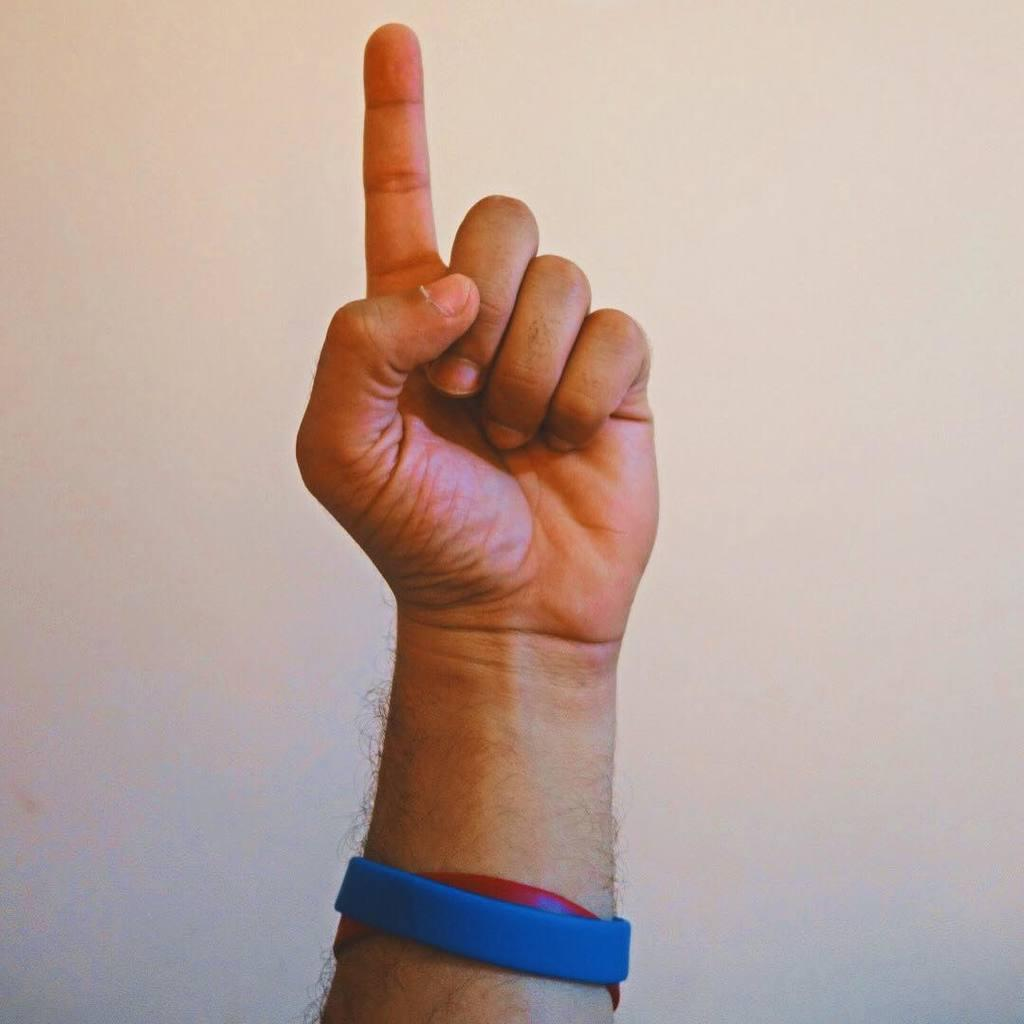What is the main subject in the center of the image? There is a hand in the center of the image. What is on the hand in the image? There are objects on the hand. Can you describe the colors of the objects on the hand? The objects are blue and red in color. What type of paper is being used to change the color of the straw in the image? There is no paper, change, or straw present in the image. 